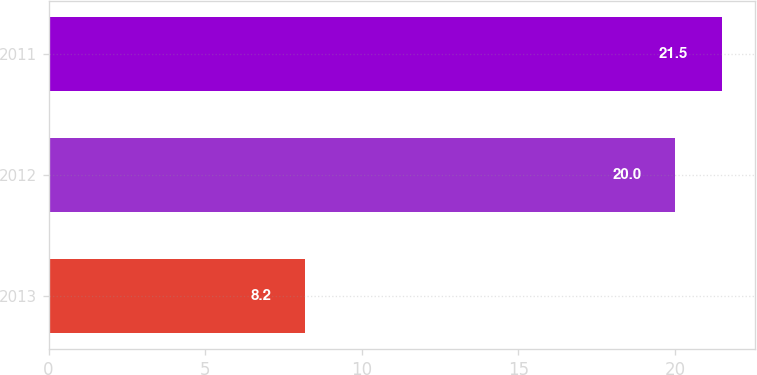Convert chart. <chart><loc_0><loc_0><loc_500><loc_500><bar_chart><fcel>2013<fcel>2012<fcel>2011<nl><fcel>8.2<fcel>20<fcel>21.5<nl></chart> 